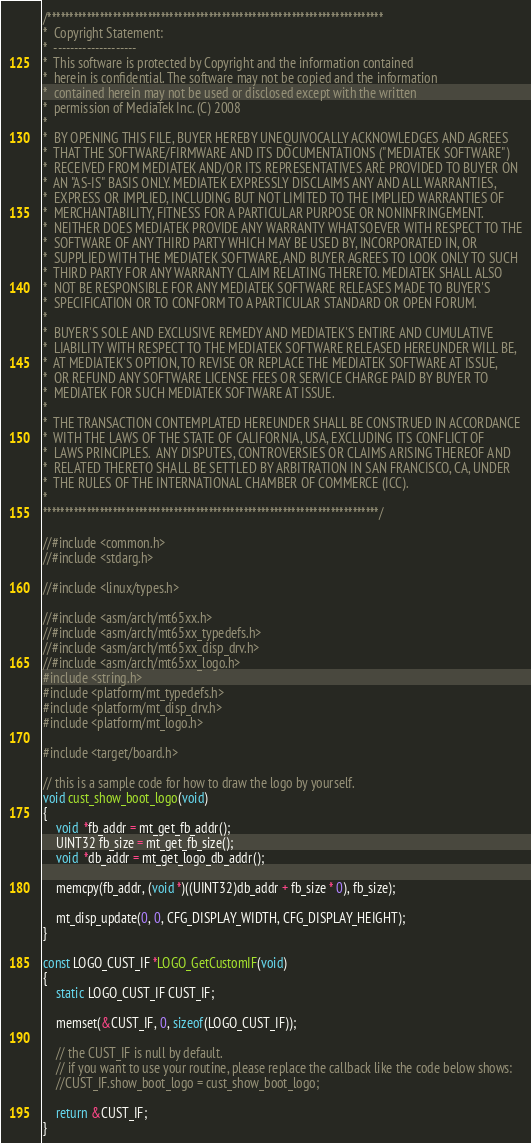<code> <loc_0><loc_0><loc_500><loc_500><_C_>/*****************************************************************************
*  Copyright Statement:
*  --------------------
*  This software is protected by Copyright and the information contained
*  herein is confidential. The software may not be copied and the information
*  contained herein may not be used or disclosed except with the written
*  permission of MediaTek Inc. (C) 2008
*
*  BY OPENING THIS FILE, BUYER HEREBY UNEQUIVOCALLY ACKNOWLEDGES AND AGREES
*  THAT THE SOFTWARE/FIRMWARE AND ITS DOCUMENTATIONS ("MEDIATEK SOFTWARE")
*  RECEIVED FROM MEDIATEK AND/OR ITS REPRESENTATIVES ARE PROVIDED TO BUYER ON
*  AN "AS-IS" BASIS ONLY. MEDIATEK EXPRESSLY DISCLAIMS ANY AND ALL WARRANTIES,
*  EXPRESS OR IMPLIED, INCLUDING BUT NOT LIMITED TO THE IMPLIED WARRANTIES OF
*  MERCHANTABILITY, FITNESS FOR A PARTICULAR PURPOSE OR NONINFRINGEMENT.
*  NEITHER DOES MEDIATEK PROVIDE ANY WARRANTY WHATSOEVER WITH RESPECT TO THE
*  SOFTWARE OF ANY THIRD PARTY WHICH MAY BE USED BY, INCORPORATED IN, OR
*  SUPPLIED WITH THE MEDIATEK SOFTWARE, AND BUYER AGREES TO LOOK ONLY TO SUCH
*  THIRD PARTY FOR ANY WARRANTY CLAIM RELATING THERETO. MEDIATEK SHALL ALSO
*  NOT BE RESPONSIBLE FOR ANY MEDIATEK SOFTWARE RELEASES MADE TO BUYER'S
*  SPECIFICATION OR TO CONFORM TO A PARTICULAR STANDARD OR OPEN FORUM.
*
*  BUYER'S SOLE AND EXCLUSIVE REMEDY AND MEDIATEK'S ENTIRE AND CUMULATIVE
*  LIABILITY WITH RESPECT TO THE MEDIATEK SOFTWARE RELEASED HEREUNDER WILL BE,
*  AT MEDIATEK'S OPTION, TO REVISE OR REPLACE THE MEDIATEK SOFTWARE AT ISSUE,
*  OR REFUND ANY SOFTWARE LICENSE FEES OR SERVICE CHARGE PAID BY BUYER TO
*  MEDIATEK FOR SUCH MEDIATEK SOFTWARE AT ISSUE.
*
*  THE TRANSACTION CONTEMPLATED HEREUNDER SHALL BE CONSTRUED IN ACCORDANCE
*  WITH THE LAWS OF THE STATE OF CALIFORNIA, USA, EXCLUDING ITS CONFLICT OF
*  LAWS PRINCIPLES.  ANY DISPUTES, CONTROVERSIES OR CLAIMS ARISING THEREOF AND
*  RELATED THERETO SHALL BE SETTLED BY ARBITRATION IN SAN FRANCISCO, CA, UNDER
*  THE RULES OF THE INTERNATIONAL CHAMBER OF COMMERCE (ICC).
*
*****************************************************************************/

//#include <common.h>
//#include <stdarg.h>

//#include <linux/types.h>

//#include <asm/arch/mt65xx.h>
//#include <asm/arch/mt65xx_typedefs.h>
//#include <asm/arch/mt65xx_disp_drv.h>
//#include <asm/arch/mt65xx_logo.h>
#include <string.h>
#include <platform/mt_typedefs.h>
#include <platform/mt_disp_drv.h>
#include <platform/mt_logo.h>

#include <target/board.h>

// this is a sample code for how to draw the logo by yourself.
void cust_show_boot_logo(void)
{
    void  *fb_addr = mt_get_fb_addr();
    UINT32 fb_size = mt_get_fb_size();
    void  *db_addr = mt_get_logo_db_addr();

    memcpy(fb_addr, (void *)((UINT32)db_addr + fb_size * 0), fb_size);

    mt_disp_update(0, 0, CFG_DISPLAY_WIDTH, CFG_DISPLAY_HEIGHT);
}

const LOGO_CUST_IF *LOGO_GetCustomIF(void)
{
    static LOGO_CUST_IF CUST_IF;

    memset(&CUST_IF, 0, sizeof(LOGO_CUST_IF));
   
    // the CUST_IF is null by default.
    // if you want to use your routine, please replace the callback like the code below shows:
    //CUST_IF.show_boot_logo = cust_show_boot_logo;

    return &CUST_IF;
}


</code> 